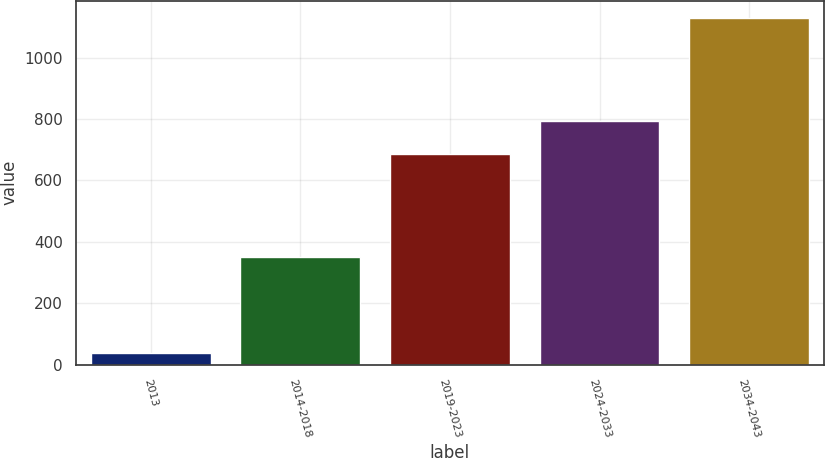Convert chart to OTSL. <chart><loc_0><loc_0><loc_500><loc_500><bar_chart><fcel>2013<fcel>2014-2018<fcel>2019-2023<fcel>2024-2033<fcel>2034-2043<nl><fcel>38<fcel>351<fcel>685<fcel>794.1<fcel>1129<nl></chart> 